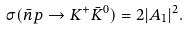<formula> <loc_0><loc_0><loc_500><loc_500>\sigma ( \bar { n } p \to K ^ { + } \bar { K } ^ { 0 } ) = 2 | A _ { 1 } | ^ { 2 } .</formula> 